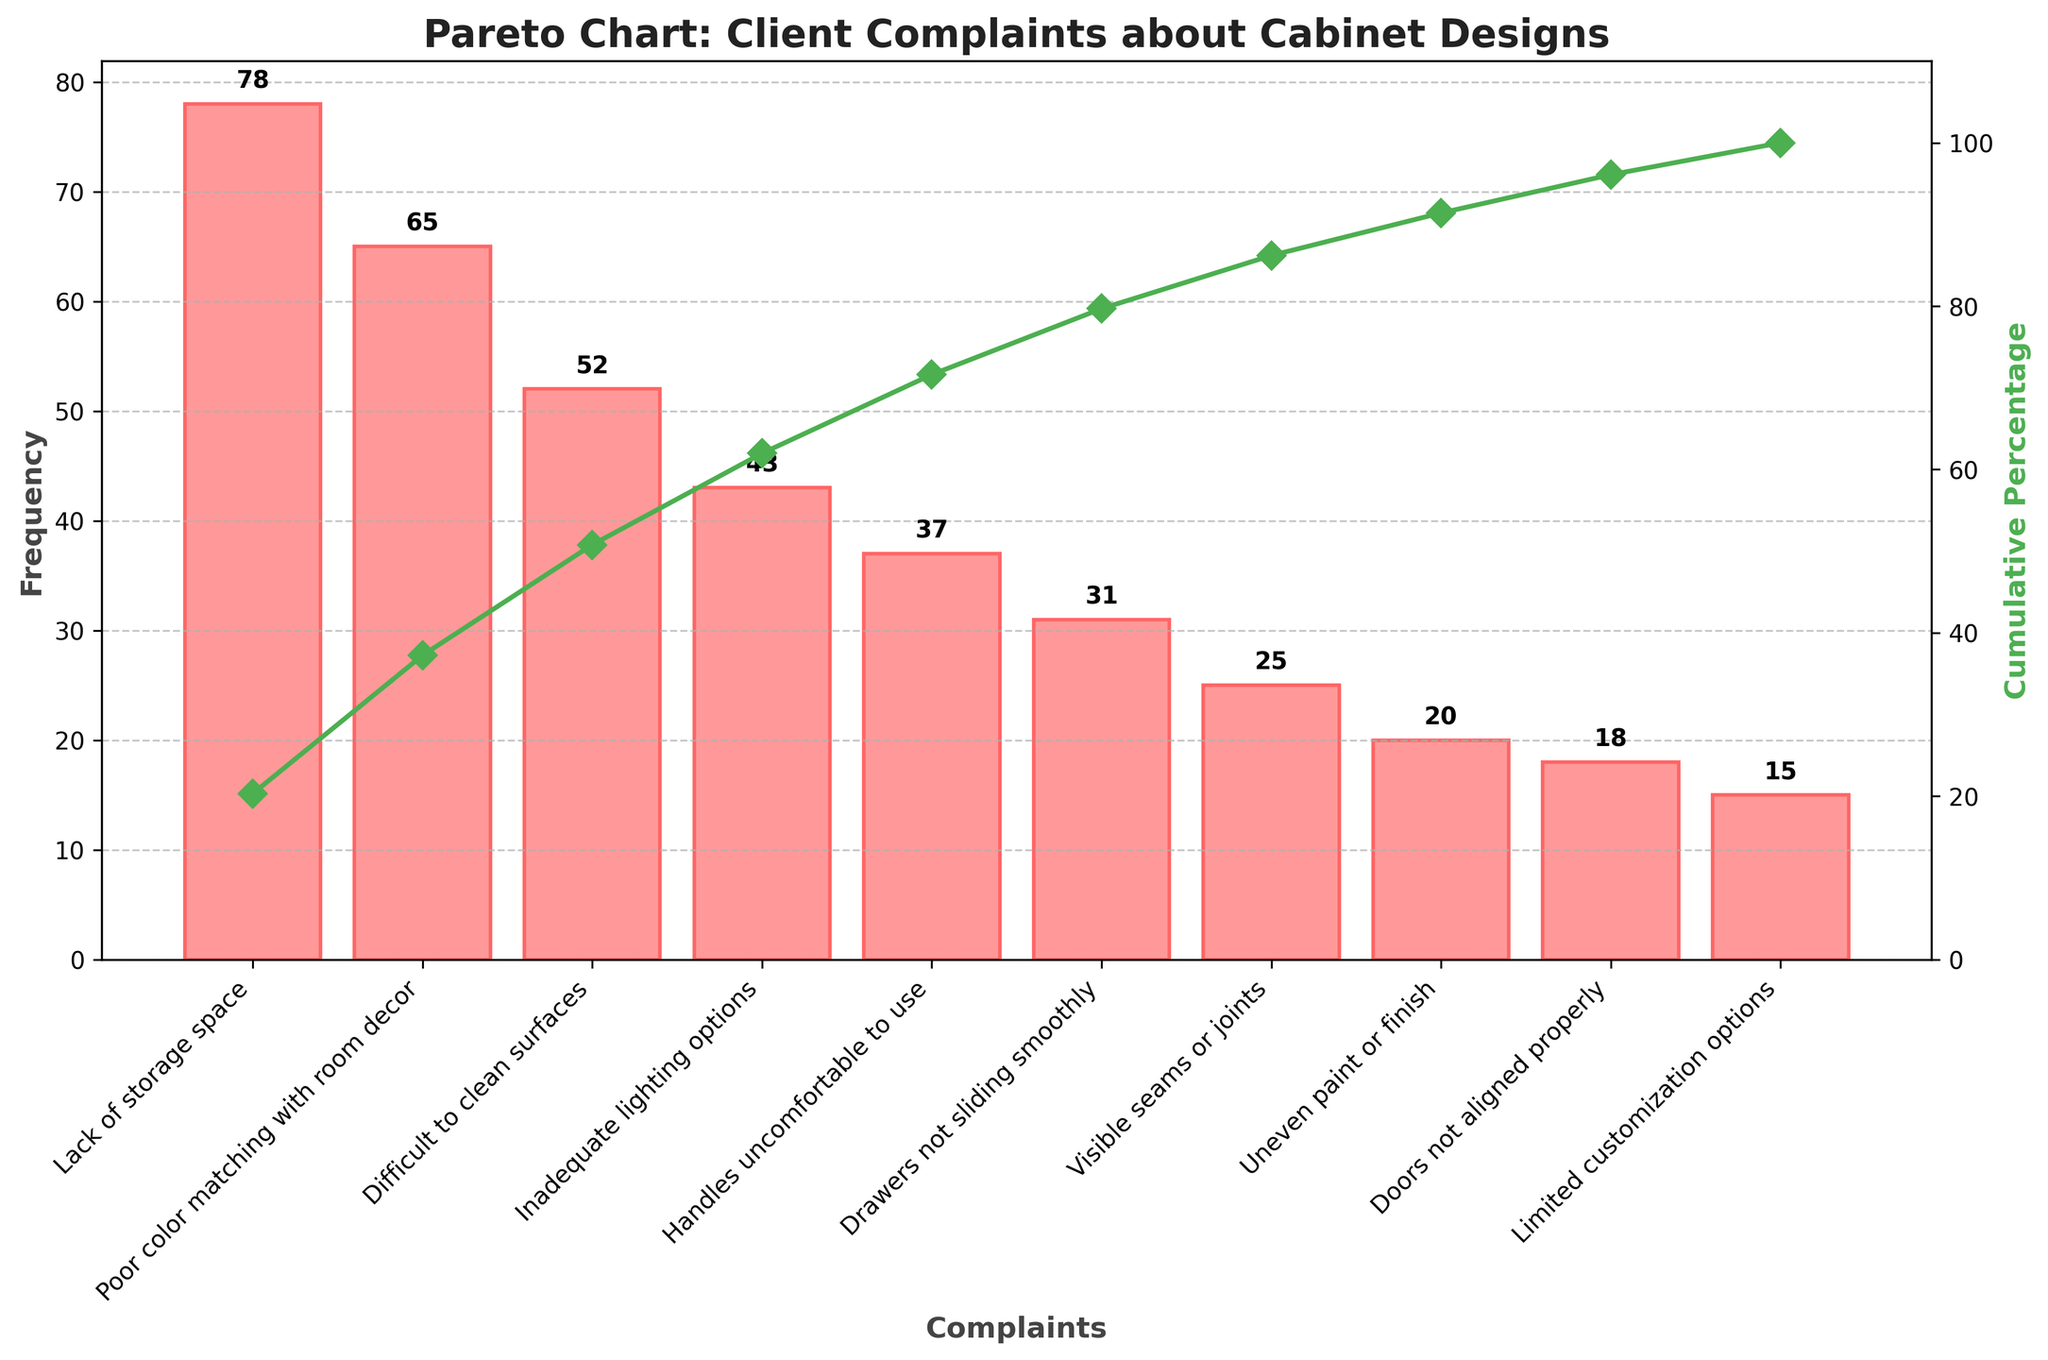What's the title of the figure? The title is located at the top of the figure and reads "Pareto Chart: Client Complaints about Cabinet Designs".
Answer: Pareto Chart: Client Complaints about Cabinet Designs What complaint has the highest frequency? The tallest bar in the figure represents the complaint with the highest frequency, which is labeled "Lack of storage space".
Answer: Lack of storage space How many complaints have a frequency greater than 50? By examining the heights of the bars, "Lack of storage space", "Poor color matching with room decor", and "Difficult to clean surfaces" have frequencies greater than 50.
Answer: 3 What is the cumulative percentage for "Handles uncomfortable to use"? The cumulative percentage can be found by following the green line's marker over the bar labeled "Handles uncomfortable to use".
Answer: Just under 80% What is the total cumulative percentage after the first complaint? The cumulative percentage for the first complaint "Lack of storage space" is at the top of the first bar and matches the green line's marker.
Answer: Close to 30% Which complaint has the lowest frequency, and what is it? The shortest bar represents the complaint with the lowest frequency, labeled "Limited customization options".
Answer: Limited customization options, 15 What are the cumulative percentages for the first two complaints? Adding the heights of the first two bars from "Lack of storage space" and "Poor color matching with room decor" and referring to the green line's markers provides these cumulative percentages.
Answer: Approximately 30% and 55% How many complaints have a frequency below 30? By examining the bars, the complaints with frequencies below 30 are "Visible seams or joints", "Uneven paint or finish", "Doors not aligned properly", and "Limited customization options".
Answer: 4 Which complaint ranks 4th in frequency? By counting the bars from left to right, the 4th bar corresponds to "Inadequate lighting options".
Answer: Inadequate lighting options By what percentage does "Lack of storage space" exceed "Handles uncomfortable to use"? Subtract the frequency of "Handles uncomfortable to use" from "Lack of storage space" and divide by the frequency of "Handles uncomfortable to use", then multiply by 100 to find the percentage.
Answer: (78 - 37) / 37 * 100 = 111.35% 